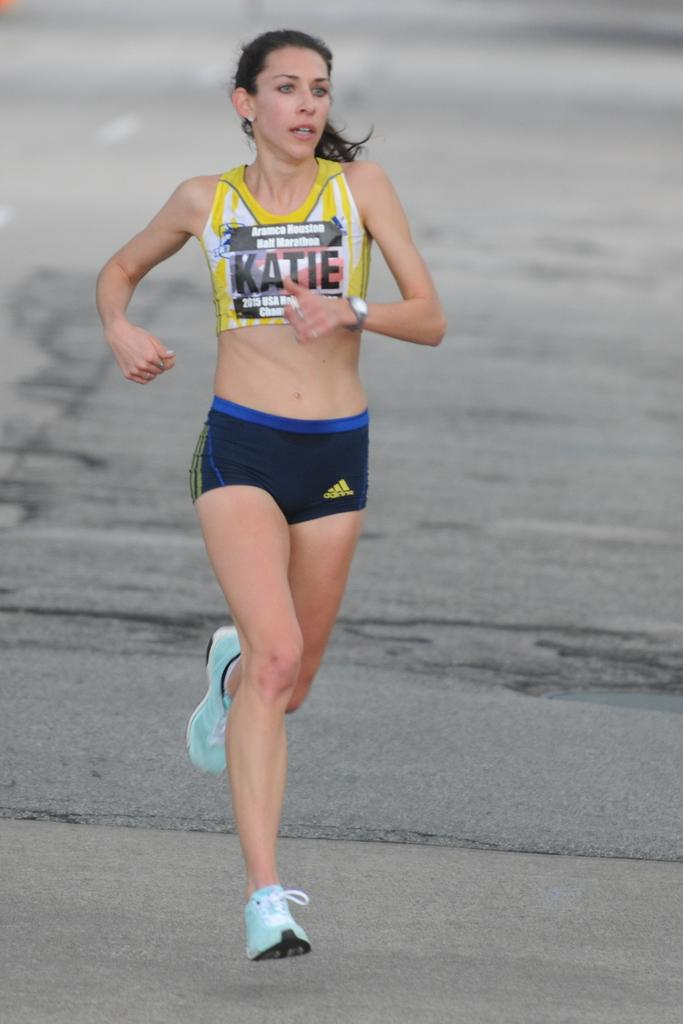<image>
Offer a succinct explanation of the picture presented. a person with the name Katie on her bib is running in a race 